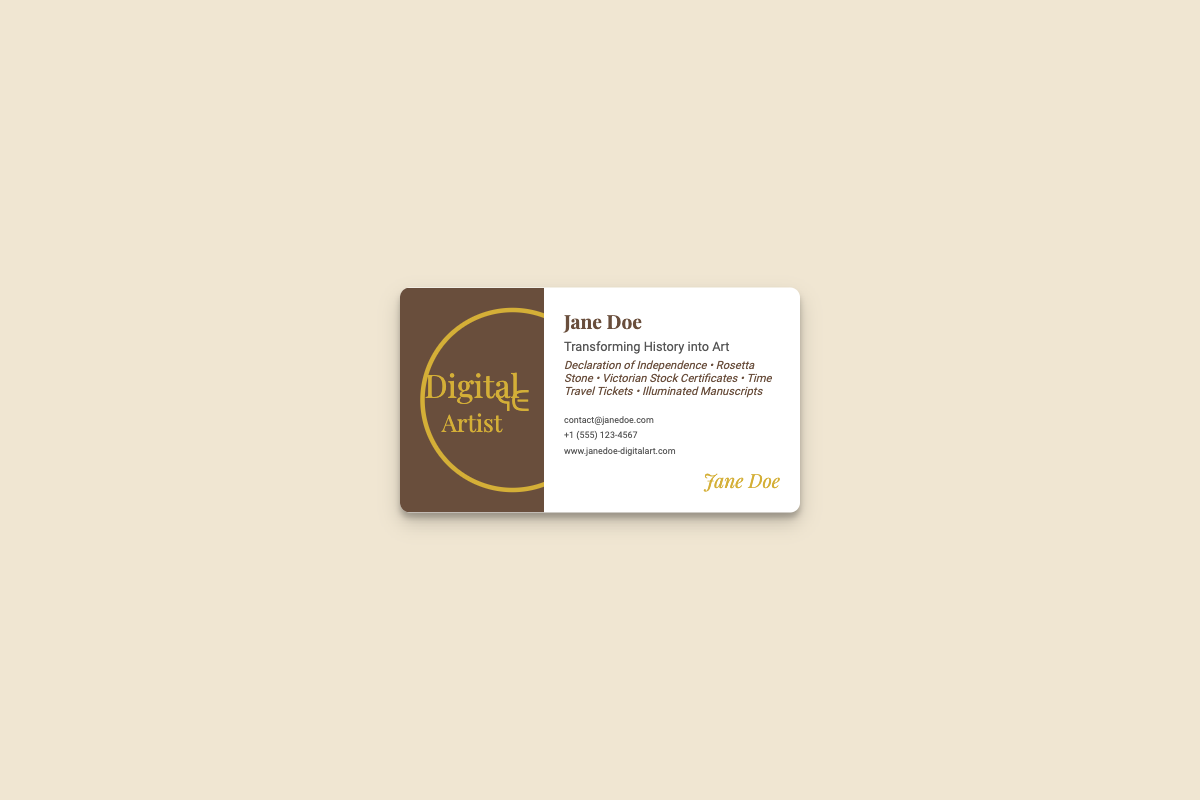What is the artist's name? The artist's name is shown prominently on the card as "Jane Doe."
Answer: Jane Doe What type of art does Jane Doe create? The document specifies that she transforms historical accounts into art, particularly mentioning certain themes in the text.
Answer: Transforming History into Art What are the artwork themes listed? The card lists specific artwork themes under "artwork types," which are relevant historical documents.
Answer: Declaration of Independence • Rosetta Stone • Victorian Stock Certificates • Time Travel Tickets • Illuminated Manuscripts What is Jane Doe's contact email? Her email address is included in the contact section of the card, providing a means to reach her for inquiries.
Answer: contact@janedoe.com Which font is used for the artist's name? The document mentions a specific font family used for the artist's name, suggesting a style.
Answer: Playfair Display How many phone numbers are listed? The contact section contains only one phone number listed for the artist.
Answer: 1 What is the background color of the card? The background color of the entire card is visible in the styling section, which creates a specific look for the card.
Answer: #f0e6d2 What does the left side of the card feature? The left side of the card specifically displays text indicating the professional identity of the artist.
Answer: Digital Artist What is the size of the card? The dimensions of the card are mentioned in the styling, indicating its physical size.
Answer: 400px by 225px 